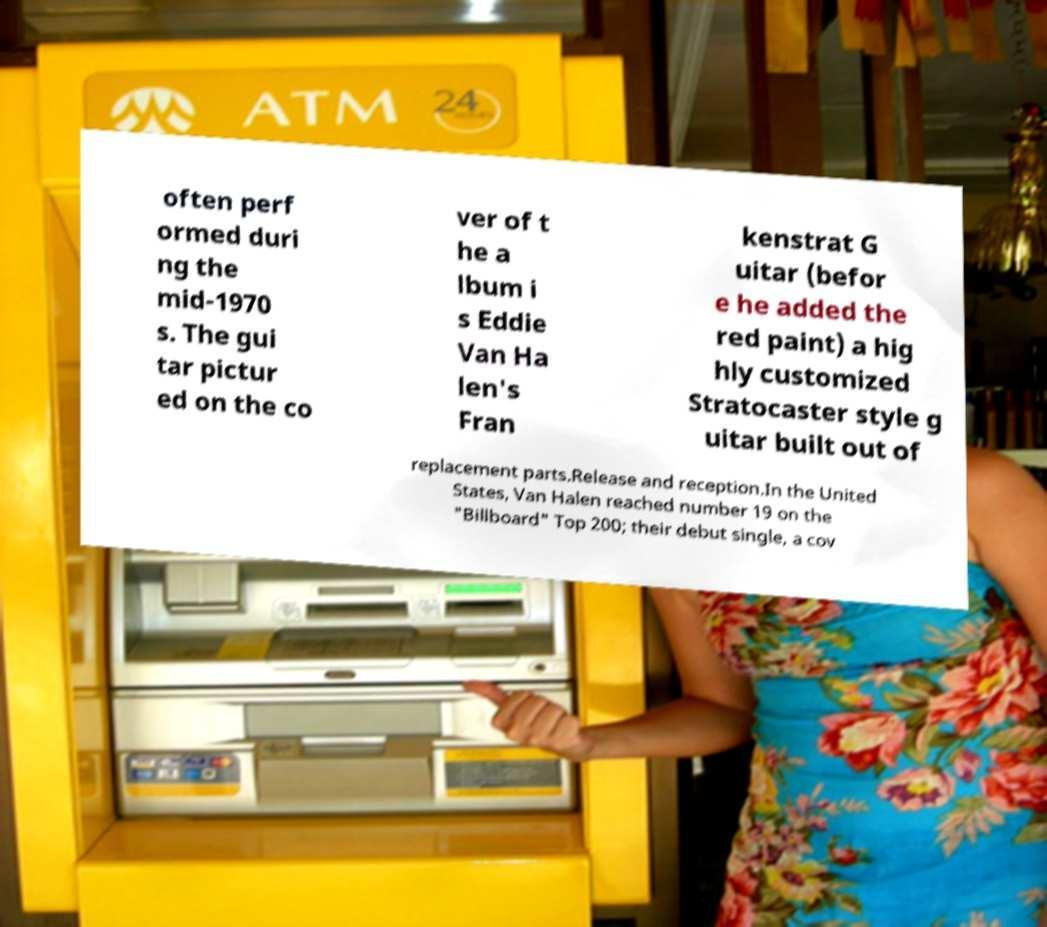There's text embedded in this image that I need extracted. Can you transcribe it verbatim? often perf ormed duri ng the mid-1970 s. The gui tar pictur ed on the co ver of t he a lbum i s Eddie Van Ha len's Fran kenstrat G uitar (befor e he added the red paint) a hig hly customized Stratocaster style g uitar built out of replacement parts.Release and reception.In the United States, Van Halen reached number 19 on the "Billboard" Top 200; their debut single, a cov 